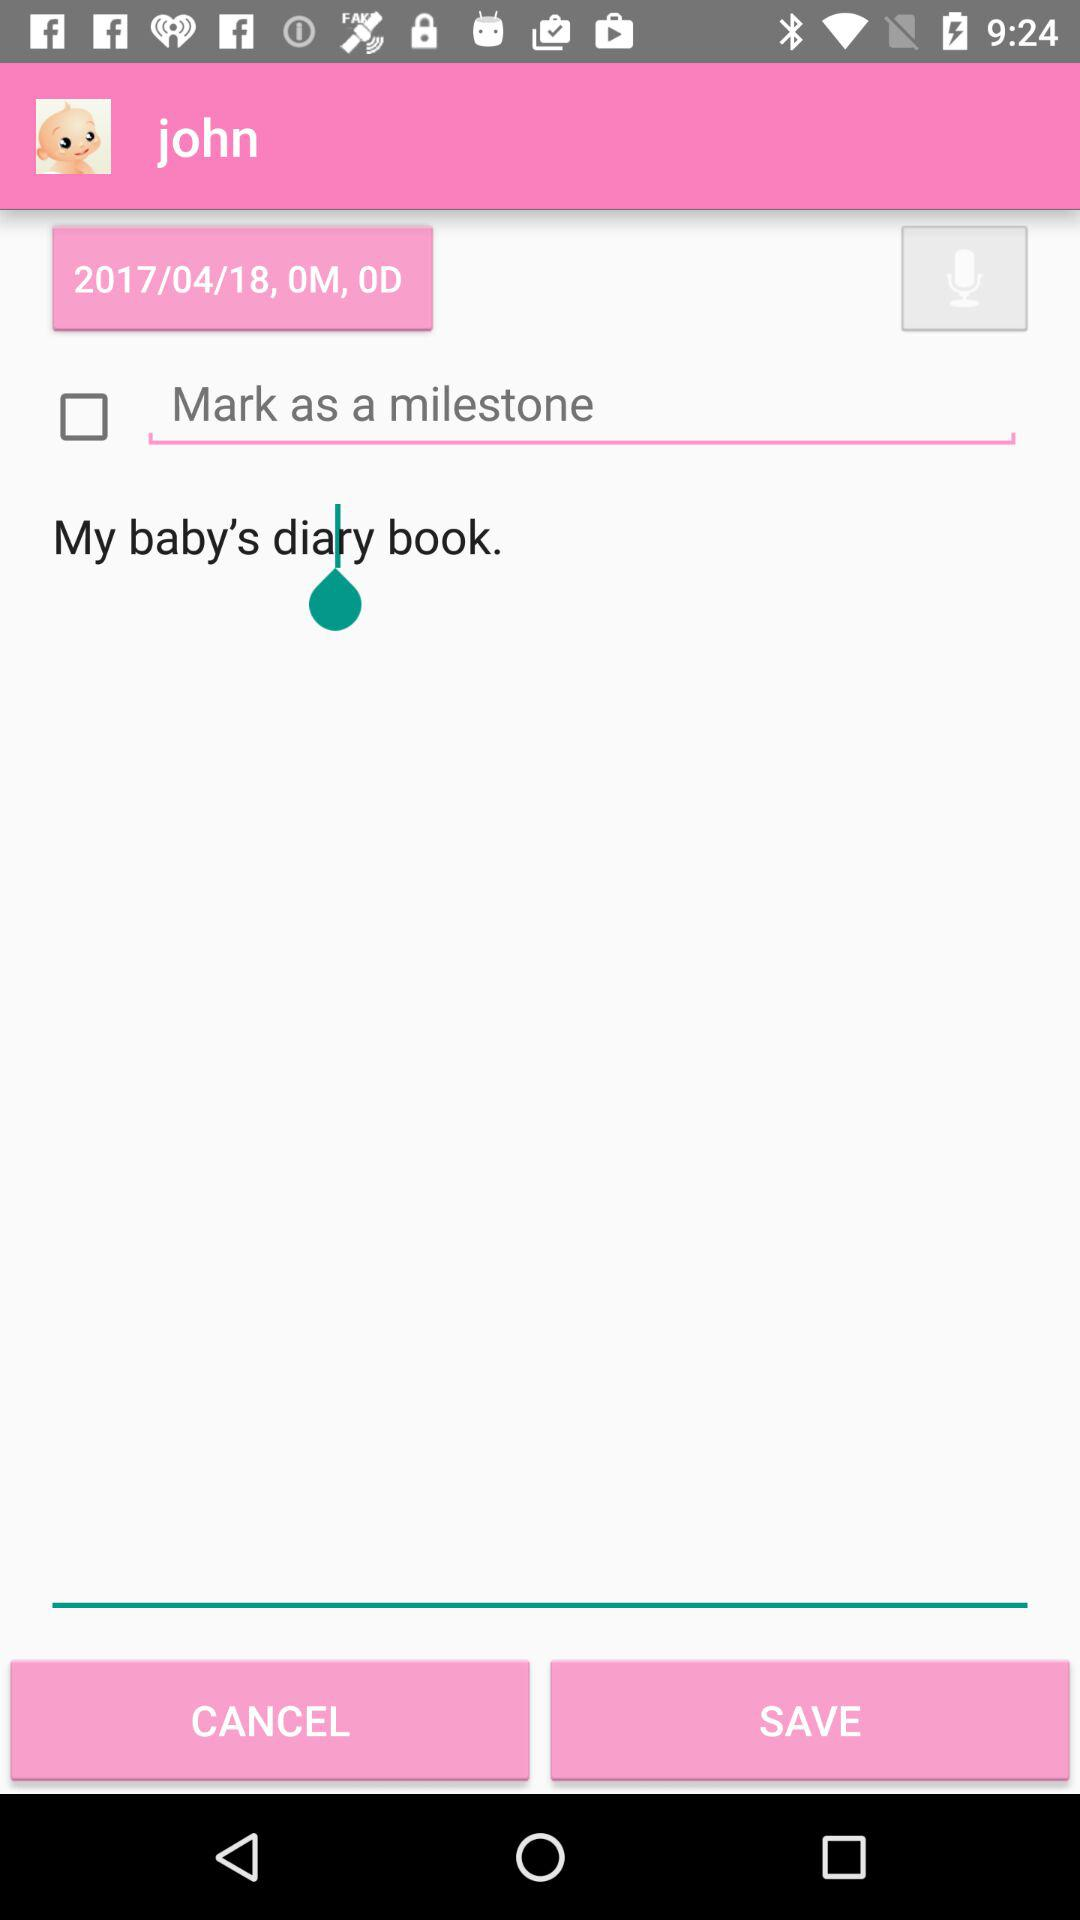How many text inputs are there that are not clickable?
Answer the question using a single word or phrase. 2 